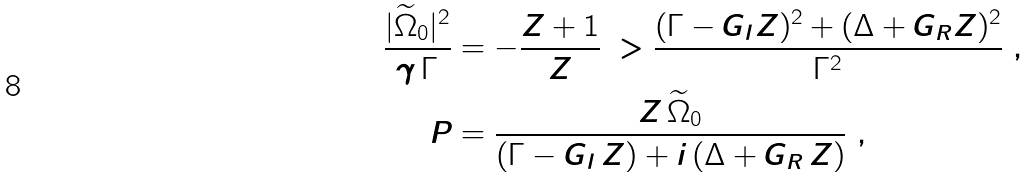Convert formula to latex. <formula><loc_0><loc_0><loc_500><loc_500>\frac { | \widetilde { \Omega } _ { 0 } | ^ { 2 } } { \gamma \, \Gamma } & = - \frac { Z + 1 } { Z } \ > \frac { ( \Gamma - G _ { I } Z ) ^ { 2 } + ( \Delta + G _ { R } Z ) ^ { 2 } } { \Gamma ^ { 2 } } \ , \\ P & = \frac { Z \, \widetilde { \Omega } _ { 0 } } { ( \Gamma - G _ { I } \, Z ) + i \, ( \Delta + G _ { R } \, Z ) } \ ,</formula> 